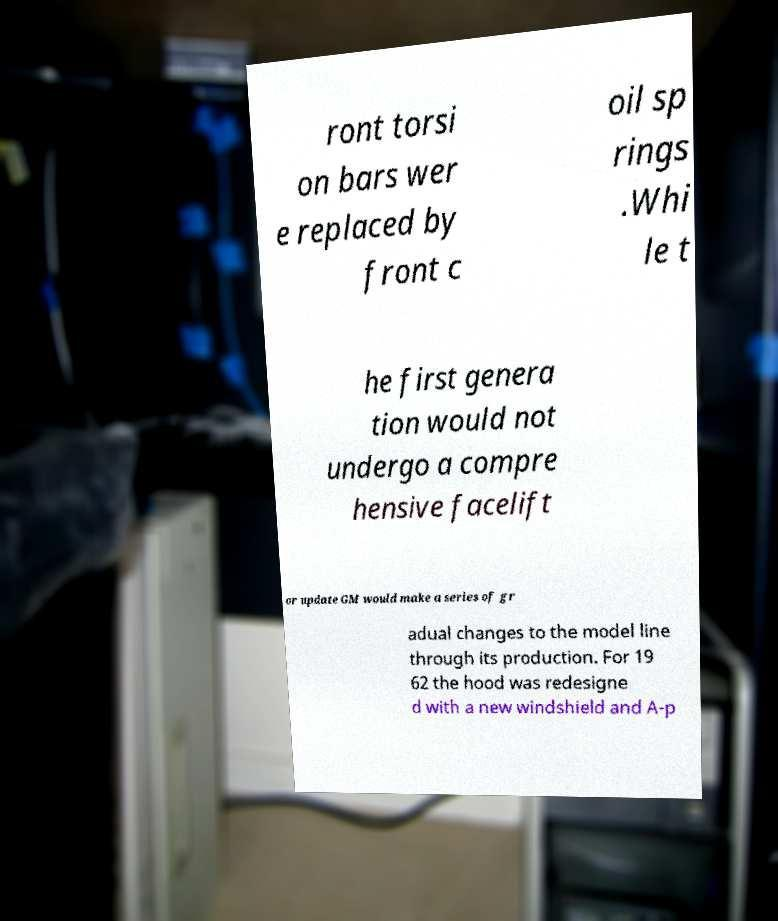Can you accurately transcribe the text from the provided image for me? ront torsi on bars wer e replaced by front c oil sp rings .Whi le t he first genera tion would not undergo a compre hensive facelift or update GM would make a series of gr adual changes to the model line through its production. For 19 62 the hood was redesigne d with a new windshield and A-p 